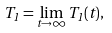<formula> <loc_0><loc_0><loc_500><loc_500>T _ { 1 } = \lim _ { t \to \infty } T _ { 1 } ( t ) ,</formula> 